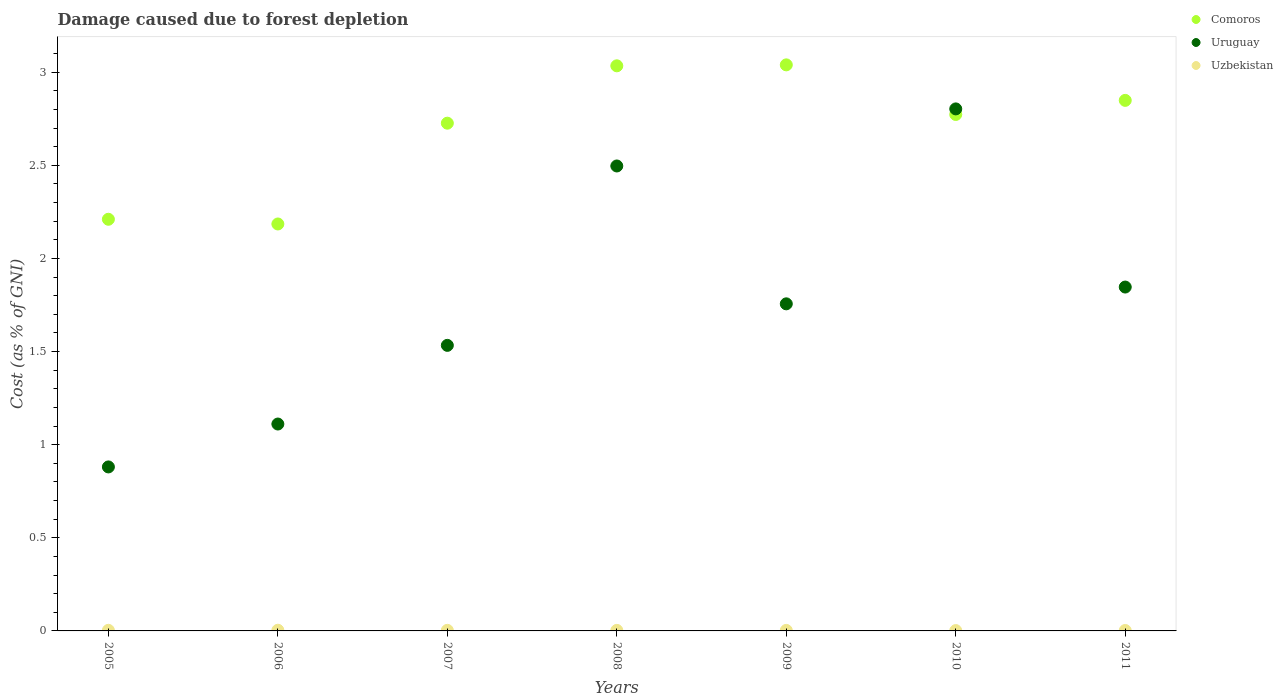How many different coloured dotlines are there?
Keep it short and to the point. 3. Is the number of dotlines equal to the number of legend labels?
Give a very brief answer. Yes. What is the cost of damage caused due to forest depletion in Uruguay in 2008?
Your answer should be very brief. 2.5. Across all years, what is the maximum cost of damage caused due to forest depletion in Uzbekistan?
Provide a short and direct response. 0. Across all years, what is the minimum cost of damage caused due to forest depletion in Comoros?
Ensure brevity in your answer.  2.18. In which year was the cost of damage caused due to forest depletion in Uzbekistan maximum?
Make the answer very short. 2006. What is the total cost of damage caused due to forest depletion in Comoros in the graph?
Offer a very short reply. 18.82. What is the difference between the cost of damage caused due to forest depletion in Uruguay in 2005 and that in 2007?
Your response must be concise. -0.65. What is the difference between the cost of damage caused due to forest depletion in Uzbekistan in 2008 and the cost of damage caused due to forest depletion in Uruguay in 2007?
Your answer should be compact. -1.53. What is the average cost of damage caused due to forest depletion in Comoros per year?
Provide a short and direct response. 2.69. In the year 2008, what is the difference between the cost of damage caused due to forest depletion in Comoros and cost of damage caused due to forest depletion in Uruguay?
Ensure brevity in your answer.  0.54. In how many years, is the cost of damage caused due to forest depletion in Uzbekistan greater than 1 %?
Your answer should be compact. 0. What is the ratio of the cost of damage caused due to forest depletion in Comoros in 2007 to that in 2011?
Offer a very short reply. 0.96. What is the difference between the highest and the second highest cost of damage caused due to forest depletion in Comoros?
Provide a short and direct response. 0.01. What is the difference between the highest and the lowest cost of damage caused due to forest depletion in Uruguay?
Your answer should be very brief. 1.92. Is the sum of the cost of damage caused due to forest depletion in Comoros in 2007 and 2011 greater than the maximum cost of damage caused due to forest depletion in Uruguay across all years?
Offer a terse response. Yes. Is it the case that in every year, the sum of the cost of damage caused due to forest depletion in Uruguay and cost of damage caused due to forest depletion in Comoros  is greater than the cost of damage caused due to forest depletion in Uzbekistan?
Make the answer very short. Yes. Does the cost of damage caused due to forest depletion in Comoros monotonically increase over the years?
Give a very brief answer. No. Is the cost of damage caused due to forest depletion in Uzbekistan strictly greater than the cost of damage caused due to forest depletion in Uruguay over the years?
Make the answer very short. No. Is the cost of damage caused due to forest depletion in Comoros strictly less than the cost of damage caused due to forest depletion in Uruguay over the years?
Make the answer very short. No. How many dotlines are there?
Give a very brief answer. 3. What is the difference between two consecutive major ticks on the Y-axis?
Your answer should be compact. 0.5. Are the values on the major ticks of Y-axis written in scientific E-notation?
Offer a very short reply. No. Does the graph contain any zero values?
Your answer should be compact. No. Does the graph contain grids?
Provide a succinct answer. No. How many legend labels are there?
Give a very brief answer. 3. How are the legend labels stacked?
Provide a succinct answer. Vertical. What is the title of the graph?
Keep it short and to the point. Damage caused due to forest depletion. What is the label or title of the X-axis?
Your response must be concise. Years. What is the label or title of the Y-axis?
Give a very brief answer. Cost (as % of GNI). What is the Cost (as % of GNI) of Comoros in 2005?
Offer a terse response. 2.21. What is the Cost (as % of GNI) in Uruguay in 2005?
Your answer should be compact. 0.88. What is the Cost (as % of GNI) in Uzbekistan in 2005?
Provide a succinct answer. 0. What is the Cost (as % of GNI) of Comoros in 2006?
Make the answer very short. 2.18. What is the Cost (as % of GNI) of Uruguay in 2006?
Your answer should be very brief. 1.11. What is the Cost (as % of GNI) of Uzbekistan in 2006?
Ensure brevity in your answer.  0. What is the Cost (as % of GNI) of Comoros in 2007?
Give a very brief answer. 2.73. What is the Cost (as % of GNI) in Uruguay in 2007?
Give a very brief answer. 1.53. What is the Cost (as % of GNI) in Uzbekistan in 2007?
Your response must be concise. 0. What is the Cost (as % of GNI) in Comoros in 2008?
Provide a short and direct response. 3.03. What is the Cost (as % of GNI) of Uruguay in 2008?
Your answer should be compact. 2.5. What is the Cost (as % of GNI) of Uzbekistan in 2008?
Give a very brief answer. 0. What is the Cost (as % of GNI) in Comoros in 2009?
Keep it short and to the point. 3.04. What is the Cost (as % of GNI) in Uruguay in 2009?
Give a very brief answer. 1.76. What is the Cost (as % of GNI) in Uzbekistan in 2009?
Provide a short and direct response. 0. What is the Cost (as % of GNI) of Comoros in 2010?
Make the answer very short. 2.77. What is the Cost (as % of GNI) in Uruguay in 2010?
Your answer should be compact. 2.8. What is the Cost (as % of GNI) in Uzbekistan in 2010?
Keep it short and to the point. 0. What is the Cost (as % of GNI) of Comoros in 2011?
Offer a very short reply. 2.85. What is the Cost (as % of GNI) in Uruguay in 2011?
Your answer should be compact. 1.85. What is the Cost (as % of GNI) in Uzbekistan in 2011?
Ensure brevity in your answer.  0. Across all years, what is the maximum Cost (as % of GNI) in Comoros?
Your answer should be very brief. 3.04. Across all years, what is the maximum Cost (as % of GNI) in Uruguay?
Provide a succinct answer. 2.8. Across all years, what is the maximum Cost (as % of GNI) of Uzbekistan?
Ensure brevity in your answer.  0. Across all years, what is the minimum Cost (as % of GNI) of Comoros?
Ensure brevity in your answer.  2.18. Across all years, what is the minimum Cost (as % of GNI) of Uruguay?
Your response must be concise. 0.88. Across all years, what is the minimum Cost (as % of GNI) of Uzbekistan?
Provide a succinct answer. 0. What is the total Cost (as % of GNI) of Comoros in the graph?
Offer a very short reply. 18.82. What is the total Cost (as % of GNI) in Uruguay in the graph?
Make the answer very short. 12.43. What is the total Cost (as % of GNI) in Uzbekistan in the graph?
Your answer should be very brief. 0.02. What is the difference between the Cost (as % of GNI) of Comoros in 2005 and that in 2006?
Your answer should be very brief. 0.03. What is the difference between the Cost (as % of GNI) of Uruguay in 2005 and that in 2006?
Make the answer very short. -0.23. What is the difference between the Cost (as % of GNI) of Uzbekistan in 2005 and that in 2006?
Provide a succinct answer. -0. What is the difference between the Cost (as % of GNI) in Comoros in 2005 and that in 2007?
Provide a succinct answer. -0.52. What is the difference between the Cost (as % of GNI) in Uruguay in 2005 and that in 2007?
Your response must be concise. -0.65. What is the difference between the Cost (as % of GNI) of Comoros in 2005 and that in 2008?
Your response must be concise. -0.82. What is the difference between the Cost (as % of GNI) of Uruguay in 2005 and that in 2008?
Your answer should be compact. -1.62. What is the difference between the Cost (as % of GNI) of Uzbekistan in 2005 and that in 2008?
Give a very brief answer. 0. What is the difference between the Cost (as % of GNI) of Comoros in 2005 and that in 2009?
Provide a short and direct response. -0.83. What is the difference between the Cost (as % of GNI) in Uruguay in 2005 and that in 2009?
Provide a succinct answer. -0.88. What is the difference between the Cost (as % of GNI) in Comoros in 2005 and that in 2010?
Your answer should be compact. -0.56. What is the difference between the Cost (as % of GNI) of Uruguay in 2005 and that in 2010?
Your response must be concise. -1.92. What is the difference between the Cost (as % of GNI) of Uzbekistan in 2005 and that in 2010?
Your answer should be compact. 0. What is the difference between the Cost (as % of GNI) in Comoros in 2005 and that in 2011?
Your answer should be very brief. -0.64. What is the difference between the Cost (as % of GNI) of Uruguay in 2005 and that in 2011?
Provide a short and direct response. -0.97. What is the difference between the Cost (as % of GNI) of Uzbekistan in 2005 and that in 2011?
Your answer should be very brief. 0. What is the difference between the Cost (as % of GNI) of Comoros in 2006 and that in 2007?
Provide a short and direct response. -0.54. What is the difference between the Cost (as % of GNI) in Uruguay in 2006 and that in 2007?
Provide a succinct answer. -0.42. What is the difference between the Cost (as % of GNI) in Uzbekistan in 2006 and that in 2007?
Ensure brevity in your answer.  0. What is the difference between the Cost (as % of GNI) in Comoros in 2006 and that in 2008?
Make the answer very short. -0.85. What is the difference between the Cost (as % of GNI) in Uruguay in 2006 and that in 2008?
Offer a terse response. -1.39. What is the difference between the Cost (as % of GNI) in Uzbekistan in 2006 and that in 2008?
Your answer should be compact. 0. What is the difference between the Cost (as % of GNI) in Comoros in 2006 and that in 2009?
Give a very brief answer. -0.85. What is the difference between the Cost (as % of GNI) of Uruguay in 2006 and that in 2009?
Your answer should be compact. -0.65. What is the difference between the Cost (as % of GNI) in Uzbekistan in 2006 and that in 2009?
Ensure brevity in your answer.  0. What is the difference between the Cost (as % of GNI) in Comoros in 2006 and that in 2010?
Your answer should be compact. -0.59. What is the difference between the Cost (as % of GNI) in Uruguay in 2006 and that in 2010?
Ensure brevity in your answer.  -1.69. What is the difference between the Cost (as % of GNI) in Uzbekistan in 2006 and that in 2010?
Your response must be concise. 0. What is the difference between the Cost (as % of GNI) of Comoros in 2006 and that in 2011?
Your answer should be compact. -0.66. What is the difference between the Cost (as % of GNI) of Uruguay in 2006 and that in 2011?
Your answer should be very brief. -0.74. What is the difference between the Cost (as % of GNI) in Uzbekistan in 2006 and that in 2011?
Your answer should be compact. 0. What is the difference between the Cost (as % of GNI) in Comoros in 2007 and that in 2008?
Offer a terse response. -0.31. What is the difference between the Cost (as % of GNI) in Uruguay in 2007 and that in 2008?
Make the answer very short. -0.96. What is the difference between the Cost (as % of GNI) of Uzbekistan in 2007 and that in 2008?
Make the answer very short. 0. What is the difference between the Cost (as % of GNI) of Comoros in 2007 and that in 2009?
Give a very brief answer. -0.31. What is the difference between the Cost (as % of GNI) of Uruguay in 2007 and that in 2009?
Offer a very short reply. -0.22. What is the difference between the Cost (as % of GNI) of Uzbekistan in 2007 and that in 2009?
Give a very brief answer. 0. What is the difference between the Cost (as % of GNI) of Comoros in 2007 and that in 2010?
Give a very brief answer. -0.05. What is the difference between the Cost (as % of GNI) in Uruguay in 2007 and that in 2010?
Provide a succinct answer. -1.27. What is the difference between the Cost (as % of GNI) of Uzbekistan in 2007 and that in 2010?
Give a very brief answer. 0. What is the difference between the Cost (as % of GNI) in Comoros in 2007 and that in 2011?
Your answer should be compact. -0.12. What is the difference between the Cost (as % of GNI) of Uruguay in 2007 and that in 2011?
Offer a terse response. -0.31. What is the difference between the Cost (as % of GNI) of Uzbekistan in 2007 and that in 2011?
Provide a short and direct response. 0. What is the difference between the Cost (as % of GNI) of Comoros in 2008 and that in 2009?
Ensure brevity in your answer.  -0.01. What is the difference between the Cost (as % of GNI) in Uruguay in 2008 and that in 2009?
Provide a short and direct response. 0.74. What is the difference between the Cost (as % of GNI) in Comoros in 2008 and that in 2010?
Your answer should be very brief. 0.26. What is the difference between the Cost (as % of GNI) of Uruguay in 2008 and that in 2010?
Your answer should be compact. -0.31. What is the difference between the Cost (as % of GNI) of Uzbekistan in 2008 and that in 2010?
Your response must be concise. 0. What is the difference between the Cost (as % of GNI) in Comoros in 2008 and that in 2011?
Offer a terse response. 0.19. What is the difference between the Cost (as % of GNI) of Uruguay in 2008 and that in 2011?
Offer a very short reply. 0.65. What is the difference between the Cost (as % of GNI) in Comoros in 2009 and that in 2010?
Provide a succinct answer. 0.27. What is the difference between the Cost (as % of GNI) in Uruguay in 2009 and that in 2010?
Keep it short and to the point. -1.05. What is the difference between the Cost (as % of GNI) in Comoros in 2009 and that in 2011?
Offer a very short reply. 0.19. What is the difference between the Cost (as % of GNI) of Uruguay in 2009 and that in 2011?
Ensure brevity in your answer.  -0.09. What is the difference between the Cost (as % of GNI) of Uzbekistan in 2009 and that in 2011?
Give a very brief answer. 0. What is the difference between the Cost (as % of GNI) in Comoros in 2010 and that in 2011?
Offer a very short reply. -0.08. What is the difference between the Cost (as % of GNI) in Uruguay in 2010 and that in 2011?
Offer a terse response. 0.96. What is the difference between the Cost (as % of GNI) in Uzbekistan in 2010 and that in 2011?
Make the answer very short. -0. What is the difference between the Cost (as % of GNI) in Comoros in 2005 and the Cost (as % of GNI) in Uruguay in 2006?
Your answer should be very brief. 1.1. What is the difference between the Cost (as % of GNI) of Comoros in 2005 and the Cost (as % of GNI) of Uzbekistan in 2006?
Offer a terse response. 2.21. What is the difference between the Cost (as % of GNI) of Uruguay in 2005 and the Cost (as % of GNI) of Uzbekistan in 2006?
Your answer should be very brief. 0.88. What is the difference between the Cost (as % of GNI) of Comoros in 2005 and the Cost (as % of GNI) of Uruguay in 2007?
Keep it short and to the point. 0.68. What is the difference between the Cost (as % of GNI) in Comoros in 2005 and the Cost (as % of GNI) in Uzbekistan in 2007?
Provide a succinct answer. 2.21. What is the difference between the Cost (as % of GNI) in Uruguay in 2005 and the Cost (as % of GNI) in Uzbekistan in 2007?
Give a very brief answer. 0.88. What is the difference between the Cost (as % of GNI) in Comoros in 2005 and the Cost (as % of GNI) in Uruguay in 2008?
Keep it short and to the point. -0.29. What is the difference between the Cost (as % of GNI) in Comoros in 2005 and the Cost (as % of GNI) in Uzbekistan in 2008?
Your answer should be compact. 2.21. What is the difference between the Cost (as % of GNI) in Uruguay in 2005 and the Cost (as % of GNI) in Uzbekistan in 2008?
Your answer should be very brief. 0.88. What is the difference between the Cost (as % of GNI) of Comoros in 2005 and the Cost (as % of GNI) of Uruguay in 2009?
Offer a terse response. 0.45. What is the difference between the Cost (as % of GNI) in Comoros in 2005 and the Cost (as % of GNI) in Uzbekistan in 2009?
Your answer should be compact. 2.21. What is the difference between the Cost (as % of GNI) in Uruguay in 2005 and the Cost (as % of GNI) in Uzbekistan in 2009?
Your answer should be compact. 0.88. What is the difference between the Cost (as % of GNI) of Comoros in 2005 and the Cost (as % of GNI) of Uruguay in 2010?
Keep it short and to the point. -0.59. What is the difference between the Cost (as % of GNI) of Comoros in 2005 and the Cost (as % of GNI) of Uzbekistan in 2010?
Your answer should be compact. 2.21. What is the difference between the Cost (as % of GNI) of Uruguay in 2005 and the Cost (as % of GNI) of Uzbekistan in 2010?
Your response must be concise. 0.88. What is the difference between the Cost (as % of GNI) of Comoros in 2005 and the Cost (as % of GNI) of Uruguay in 2011?
Your answer should be compact. 0.36. What is the difference between the Cost (as % of GNI) in Comoros in 2005 and the Cost (as % of GNI) in Uzbekistan in 2011?
Keep it short and to the point. 2.21. What is the difference between the Cost (as % of GNI) of Uruguay in 2005 and the Cost (as % of GNI) of Uzbekistan in 2011?
Offer a very short reply. 0.88. What is the difference between the Cost (as % of GNI) of Comoros in 2006 and the Cost (as % of GNI) of Uruguay in 2007?
Your response must be concise. 0.65. What is the difference between the Cost (as % of GNI) of Comoros in 2006 and the Cost (as % of GNI) of Uzbekistan in 2007?
Offer a very short reply. 2.18. What is the difference between the Cost (as % of GNI) in Uruguay in 2006 and the Cost (as % of GNI) in Uzbekistan in 2007?
Give a very brief answer. 1.11. What is the difference between the Cost (as % of GNI) of Comoros in 2006 and the Cost (as % of GNI) of Uruguay in 2008?
Your answer should be very brief. -0.31. What is the difference between the Cost (as % of GNI) in Comoros in 2006 and the Cost (as % of GNI) in Uzbekistan in 2008?
Ensure brevity in your answer.  2.18. What is the difference between the Cost (as % of GNI) of Uruguay in 2006 and the Cost (as % of GNI) of Uzbekistan in 2008?
Provide a short and direct response. 1.11. What is the difference between the Cost (as % of GNI) of Comoros in 2006 and the Cost (as % of GNI) of Uruguay in 2009?
Your response must be concise. 0.43. What is the difference between the Cost (as % of GNI) of Comoros in 2006 and the Cost (as % of GNI) of Uzbekistan in 2009?
Your answer should be very brief. 2.18. What is the difference between the Cost (as % of GNI) of Uruguay in 2006 and the Cost (as % of GNI) of Uzbekistan in 2009?
Your answer should be very brief. 1.11. What is the difference between the Cost (as % of GNI) of Comoros in 2006 and the Cost (as % of GNI) of Uruguay in 2010?
Make the answer very short. -0.62. What is the difference between the Cost (as % of GNI) in Comoros in 2006 and the Cost (as % of GNI) in Uzbekistan in 2010?
Keep it short and to the point. 2.18. What is the difference between the Cost (as % of GNI) of Uruguay in 2006 and the Cost (as % of GNI) of Uzbekistan in 2010?
Give a very brief answer. 1.11. What is the difference between the Cost (as % of GNI) of Comoros in 2006 and the Cost (as % of GNI) of Uruguay in 2011?
Make the answer very short. 0.34. What is the difference between the Cost (as % of GNI) of Comoros in 2006 and the Cost (as % of GNI) of Uzbekistan in 2011?
Provide a succinct answer. 2.18. What is the difference between the Cost (as % of GNI) of Uruguay in 2006 and the Cost (as % of GNI) of Uzbekistan in 2011?
Offer a very short reply. 1.11. What is the difference between the Cost (as % of GNI) in Comoros in 2007 and the Cost (as % of GNI) in Uruguay in 2008?
Provide a succinct answer. 0.23. What is the difference between the Cost (as % of GNI) of Comoros in 2007 and the Cost (as % of GNI) of Uzbekistan in 2008?
Offer a terse response. 2.72. What is the difference between the Cost (as % of GNI) of Uruguay in 2007 and the Cost (as % of GNI) of Uzbekistan in 2008?
Your answer should be very brief. 1.53. What is the difference between the Cost (as % of GNI) of Comoros in 2007 and the Cost (as % of GNI) of Uruguay in 2009?
Keep it short and to the point. 0.97. What is the difference between the Cost (as % of GNI) in Comoros in 2007 and the Cost (as % of GNI) in Uzbekistan in 2009?
Offer a terse response. 2.72. What is the difference between the Cost (as % of GNI) in Uruguay in 2007 and the Cost (as % of GNI) in Uzbekistan in 2009?
Provide a short and direct response. 1.53. What is the difference between the Cost (as % of GNI) in Comoros in 2007 and the Cost (as % of GNI) in Uruguay in 2010?
Keep it short and to the point. -0.08. What is the difference between the Cost (as % of GNI) in Comoros in 2007 and the Cost (as % of GNI) in Uzbekistan in 2010?
Keep it short and to the point. 2.72. What is the difference between the Cost (as % of GNI) in Uruguay in 2007 and the Cost (as % of GNI) in Uzbekistan in 2010?
Offer a very short reply. 1.53. What is the difference between the Cost (as % of GNI) in Comoros in 2007 and the Cost (as % of GNI) in Uruguay in 2011?
Provide a succinct answer. 0.88. What is the difference between the Cost (as % of GNI) in Comoros in 2007 and the Cost (as % of GNI) in Uzbekistan in 2011?
Offer a very short reply. 2.72. What is the difference between the Cost (as % of GNI) of Uruguay in 2007 and the Cost (as % of GNI) of Uzbekistan in 2011?
Keep it short and to the point. 1.53. What is the difference between the Cost (as % of GNI) of Comoros in 2008 and the Cost (as % of GNI) of Uruguay in 2009?
Make the answer very short. 1.28. What is the difference between the Cost (as % of GNI) in Comoros in 2008 and the Cost (as % of GNI) in Uzbekistan in 2009?
Ensure brevity in your answer.  3.03. What is the difference between the Cost (as % of GNI) in Uruguay in 2008 and the Cost (as % of GNI) in Uzbekistan in 2009?
Provide a short and direct response. 2.49. What is the difference between the Cost (as % of GNI) in Comoros in 2008 and the Cost (as % of GNI) in Uruguay in 2010?
Offer a very short reply. 0.23. What is the difference between the Cost (as % of GNI) in Comoros in 2008 and the Cost (as % of GNI) in Uzbekistan in 2010?
Make the answer very short. 3.03. What is the difference between the Cost (as % of GNI) in Uruguay in 2008 and the Cost (as % of GNI) in Uzbekistan in 2010?
Ensure brevity in your answer.  2.49. What is the difference between the Cost (as % of GNI) of Comoros in 2008 and the Cost (as % of GNI) of Uruguay in 2011?
Your answer should be compact. 1.19. What is the difference between the Cost (as % of GNI) of Comoros in 2008 and the Cost (as % of GNI) of Uzbekistan in 2011?
Ensure brevity in your answer.  3.03. What is the difference between the Cost (as % of GNI) of Uruguay in 2008 and the Cost (as % of GNI) of Uzbekistan in 2011?
Ensure brevity in your answer.  2.49. What is the difference between the Cost (as % of GNI) in Comoros in 2009 and the Cost (as % of GNI) in Uruguay in 2010?
Provide a succinct answer. 0.24. What is the difference between the Cost (as % of GNI) in Comoros in 2009 and the Cost (as % of GNI) in Uzbekistan in 2010?
Give a very brief answer. 3.04. What is the difference between the Cost (as % of GNI) of Uruguay in 2009 and the Cost (as % of GNI) of Uzbekistan in 2010?
Keep it short and to the point. 1.75. What is the difference between the Cost (as % of GNI) of Comoros in 2009 and the Cost (as % of GNI) of Uruguay in 2011?
Your answer should be compact. 1.19. What is the difference between the Cost (as % of GNI) of Comoros in 2009 and the Cost (as % of GNI) of Uzbekistan in 2011?
Offer a terse response. 3.04. What is the difference between the Cost (as % of GNI) in Uruguay in 2009 and the Cost (as % of GNI) in Uzbekistan in 2011?
Your answer should be compact. 1.75. What is the difference between the Cost (as % of GNI) in Comoros in 2010 and the Cost (as % of GNI) in Uruguay in 2011?
Make the answer very short. 0.93. What is the difference between the Cost (as % of GNI) of Comoros in 2010 and the Cost (as % of GNI) of Uzbekistan in 2011?
Give a very brief answer. 2.77. What is the difference between the Cost (as % of GNI) of Uruguay in 2010 and the Cost (as % of GNI) of Uzbekistan in 2011?
Provide a short and direct response. 2.8. What is the average Cost (as % of GNI) of Comoros per year?
Offer a terse response. 2.69. What is the average Cost (as % of GNI) of Uruguay per year?
Provide a short and direct response. 1.78. What is the average Cost (as % of GNI) of Uzbekistan per year?
Provide a short and direct response. 0. In the year 2005, what is the difference between the Cost (as % of GNI) in Comoros and Cost (as % of GNI) in Uruguay?
Make the answer very short. 1.33. In the year 2005, what is the difference between the Cost (as % of GNI) in Comoros and Cost (as % of GNI) in Uzbekistan?
Your answer should be very brief. 2.21. In the year 2005, what is the difference between the Cost (as % of GNI) of Uruguay and Cost (as % of GNI) of Uzbekistan?
Ensure brevity in your answer.  0.88. In the year 2006, what is the difference between the Cost (as % of GNI) of Comoros and Cost (as % of GNI) of Uruguay?
Make the answer very short. 1.07. In the year 2006, what is the difference between the Cost (as % of GNI) of Comoros and Cost (as % of GNI) of Uzbekistan?
Keep it short and to the point. 2.18. In the year 2006, what is the difference between the Cost (as % of GNI) of Uruguay and Cost (as % of GNI) of Uzbekistan?
Ensure brevity in your answer.  1.11. In the year 2007, what is the difference between the Cost (as % of GNI) in Comoros and Cost (as % of GNI) in Uruguay?
Your response must be concise. 1.19. In the year 2007, what is the difference between the Cost (as % of GNI) of Comoros and Cost (as % of GNI) of Uzbekistan?
Provide a short and direct response. 2.72. In the year 2007, what is the difference between the Cost (as % of GNI) in Uruguay and Cost (as % of GNI) in Uzbekistan?
Provide a short and direct response. 1.53. In the year 2008, what is the difference between the Cost (as % of GNI) in Comoros and Cost (as % of GNI) in Uruguay?
Provide a succinct answer. 0.54. In the year 2008, what is the difference between the Cost (as % of GNI) of Comoros and Cost (as % of GNI) of Uzbekistan?
Keep it short and to the point. 3.03. In the year 2008, what is the difference between the Cost (as % of GNI) in Uruguay and Cost (as % of GNI) in Uzbekistan?
Your response must be concise. 2.49. In the year 2009, what is the difference between the Cost (as % of GNI) in Comoros and Cost (as % of GNI) in Uruguay?
Make the answer very short. 1.28. In the year 2009, what is the difference between the Cost (as % of GNI) of Comoros and Cost (as % of GNI) of Uzbekistan?
Provide a succinct answer. 3.04. In the year 2009, what is the difference between the Cost (as % of GNI) of Uruguay and Cost (as % of GNI) of Uzbekistan?
Give a very brief answer. 1.75. In the year 2010, what is the difference between the Cost (as % of GNI) in Comoros and Cost (as % of GNI) in Uruguay?
Ensure brevity in your answer.  -0.03. In the year 2010, what is the difference between the Cost (as % of GNI) in Comoros and Cost (as % of GNI) in Uzbekistan?
Make the answer very short. 2.77. In the year 2010, what is the difference between the Cost (as % of GNI) in Uruguay and Cost (as % of GNI) in Uzbekistan?
Ensure brevity in your answer.  2.8. In the year 2011, what is the difference between the Cost (as % of GNI) in Comoros and Cost (as % of GNI) in Uruguay?
Provide a succinct answer. 1. In the year 2011, what is the difference between the Cost (as % of GNI) of Comoros and Cost (as % of GNI) of Uzbekistan?
Offer a very short reply. 2.85. In the year 2011, what is the difference between the Cost (as % of GNI) of Uruguay and Cost (as % of GNI) of Uzbekistan?
Your answer should be compact. 1.84. What is the ratio of the Cost (as % of GNI) of Comoros in 2005 to that in 2006?
Keep it short and to the point. 1.01. What is the ratio of the Cost (as % of GNI) of Uruguay in 2005 to that in 2006?
Provide a succinct answer. 0.79. What is the ratio of the Cost (as % of GNI) in Uzbekistan in 2005 to that in 2006?
Give a very brief answer. 0.89. What is the ratio of the Cost (as % of GNI) in Comoros in 2005 to that in 2007?
Keep it short and to the point. 0.81. What is the ratio of the Cost (as % of GNI) in Uruguay in 2005 to that in 2007?
Your response must be concise. 0.57. What is the ratio of the Cost (as % of GNI) of Uzbekistan in 2005 to that in 2007?
Give a very brief answer. 1.03. What is the ratio of the Cost (as % of GNI) of Comoros in 2005 to that in 2008?
Ensure brevity in your answer.  0.73. What is the ratio of the Cost (as % of GNI) of Uruguay in 2005 to that in 2008?
Make the answer very short. 0.35. What is the ratio of the Cost (as % of GNI) of Uzbekistan in 2005 to that in 2008?
Provide a succinct answer. 1.13. What is the ratio of the Cost (as % of GNI) in Comoros in 2005 to that in 2009?
Provide a succinct answer. 0.73. What is the ratio of the Cost (as % of GNI) in Uruguay in 2005 to that in 2009?
Your answer should be compact. 0.5. What is the ratio of the Cost (as % of GNI) of Uzbekistan in 2005 to that in 2009?
Ensure brevity in your answer.  1.15. What is the ratio of the Cost (as % of GNI) of Comoros in 2005 to that in 2010?
Ensure brevity in your answer.  0.8. What is the ratio of the Cost (as % of GNI) of Uruguay in 2005 to that in 2010?
Offer a very short reply. 0.31. What is the ratio of the Cost (as % of GNI) of Uzbekistan in 2005 to that in 2010?
Your answer should be compact. 1.74. What is the ratio of the Cost (as % of GNI) in Comoros in 2005 to that in 2011?
Your response must be concise. 0.78. What is the ratio of the Cost (as % of GNI) of Uruguay in 2005 to that in 2011?
Make the answer very short. 0.48. What is the ratio of the Cost (as % of GNI) of Uzbekistan in 2005 to that in 2011?
Make the answer very short. 1.4. What is the ratio of the Cost (as % of GNI) in Comoros in 2006 to that in 2007?
Your answer should be very brief. 0.8. What is the ratio of the Cost (as % of GNI) in Uruguay in 2006 to that in 2007?
Make the answer very short. 0.72. What is the ratio of the Cost (as % of GNI) of Uzbekistan in 2006 to that in 2007?
Provide a succinct answer. 1.16. What is the ratio of the Cost (as % of GNI) in Comoros in 2006 to that in 2008?
Keep it short and to the point. 0.72. What is the ratio of the Cost (as % of GNI) of Uruguay in 2006 to that in 2008?
Ensure brevity in your answer.  0.45. What is the ratio of the Cost (as % of GNI) in Uzbekistan in 2006 to that in 2008?
Offer a very short reply. 1.28. What is the ratio of the Cost (as % of GNI) of Comoros in 2006 to that in 2009?
Provide a short and direct response. 0.72. What is the ratio of the Cost (as % of GNI) in Uruguay in 2006 to that in 2009?
Your response must be concise. 0.63. What is the ratio of the Cost (as % of GNI) in Uzbekistan in 2006 to that in 2009?
Offer a terse response. 1.29. What is the ratio of the Cost (as % of GNI) in Comoros in 2006 to that in 2010?
Offer a terse response. 0.79. What is the ratio of the Cost (as % of GNI) of Uruguay in 2006 to that in 2010?
Your answer should be compact. 0.4. What is the ratio of the Cost (as % of GNI) of Uzbekistan in 2006 to that in 2010?
Your answer should be very brief. 1.96. What is the ratio of the Cost (as % of GNI) in Comoros in 2006 to that in 2011?
Offer a terse response. 0.77. What is the ratio of the Cost (as % of GNI) of Uruguay in 2006 to that in 2011?
Offer a terse response. 0.6. What is the ratio of the Cost (as % of GNI) of Uzbekistan in 2006 to that in 2011?
Keep it short and to the point. 1.57. What is the ratio of the Cost (as % of GNI) of Comoros in 2007 to that in 2008?
Keep it short and to the point. 0.9. What is the ratio of the Cost (as % of GNI) in Uruguay in 2007 to that in 2008?
Offer a terse response. 0.61. What is the ratio of the Cost (as % of GNI) in Uzbekistan in 2007 to that in 2008?
Provide a short and direct response. 1.1. What is the ratio of the Cost (as % of GNI) in Comoros in 2007 to that in 2009?
Ensure brevity in your answer.  0.9. What is the ratio of the Cost (as % of GNI) in Uruguay in 2007 to that in 2009?
Make the answer very short. 0.87. What is the ratio of the Cost (as % of GNI) of Uzbekistan in 2007 to that in 2009?
Your answer should be compact. 1.11. What is the ratio of the Cost (as % of GNI) of Comoros in 2007 to that in 2010?
Your answer should be compact. 0.98. What is the ratio of the Cost (as % of GNI) in Uruguay in 2007 to that in 2010?
Your answer should be very brief. 0.55. What is the ratio of the Cost (as % of GNI) of Uzbekistan in 2007 to that in 2010?
Provide a succinct answer. 1.69. What is the ratio of the Cost (as % of GNI) in Comoros in 2007 to that in 2011?
Your answer should be very brief. 0.96. What is the ratio of the Cost (as % of GNI) of Uruguay in 2007 to that in 2011?
Your response must be concise. 0.83. What is the ratio of the Cost (as % of GNI) in Uzbekistan in 2007 to that in 2011?
Offer a terse response. 1.35. What is the ratio of the Cost (as % of GNI) of Uruguay in 2008 to that in 2009?
Your response must be concise. 1.42. What is the ratio of the Cost (as % of GNI) in Uzbekistan in 2008 to that in 2009?
Your response must be concise. 1.01. What is the ratio of the Cost (as % of GNI) in Comoros in 2008 to that in 2010?
Your response must be concise. 1.09. What is the ratio of the Cost (as % of GNI) of Uruguay in 2008 to that in 2010?
Offer a very short reply. 0.89. What is the ratio of the Cost (as % of GNI) in Uzbekistan in 2008 to that in 2010?
Your answer should be compact. 1.54. What is the ratio of the Cost (as % of GNI) of Comoros in 2008 to that in 2011?
Keep it short and to the point. 1.07. What is the ratio of the Cost (as % of GNI) in Uruguay in 2008 to that in 2011?
Offer a terse response. 1.35. What is the ratio of the Cost (as % of GNI) of Uzbekistan in 2008 to that in 2011?
Make the answer very short. 1.23. What is the ratio of the Cost (as % of GNI) of Comoros in 2009 to that in 2010?
Your answer should be very brief. 1.1. What is the ratio of the Cost (as % of GNI) in Uruguay in 2009 to that in 2010?
Offer a terse response. 0.63. What is the ratio of the Cost (as % of GNI) in Uzbekistan in 2009 to that in 2010?
Your answer should be very brief. 1.52. What is the ratio of the Cost (as % of GNI) in Comoros in 2009 to that in 2011?
Your response must be concise. 1.07. What is the ratio of the Cost (as % of GNI) in Uruguay in 2009 to that in 2011?
Your response must be concise. 0.95. What is the ratio of the Cost (as % of GNI) in Uzbekistan in 2009 to that in 2011?
Make the answer very short. 1.22. What is the ratio of the Cost (as % of GNI) in Comoros in 2010 to that in 2011?
Your response must be concise. 0.97. What is the ratio of the Cost (as % of GNI) in Uruguay in 2010 to that in 2011?
Keep it short and to the point. 1.52. What is the ratio of the Cost (as % of GNI) in Uzbekistan in 2010 to that in 2011?
Offer a very short reply. 0.8. What is the difference between the highest and the second highest Cost (as % of GNI) of Comoros?
Your response must be concise. 0.01. What is the difference between the highest and the second highest Cost (as % of GNI) in Uruguay?
Give a very brief answer. 0.31. What is the difference between the highest and the lowest Cost (as % of GNI) of Comoros?
Ensure brevity in your answer.  0.85. What is the difference between the highest and the lowest Cost (as % of GNI) in Uruguay?
Your answer should be compact. 1.92. What is the difference between the highest and the lowest Cost (as % of GNI) in Uzbekistan?
Your answer should be compact. 0. 